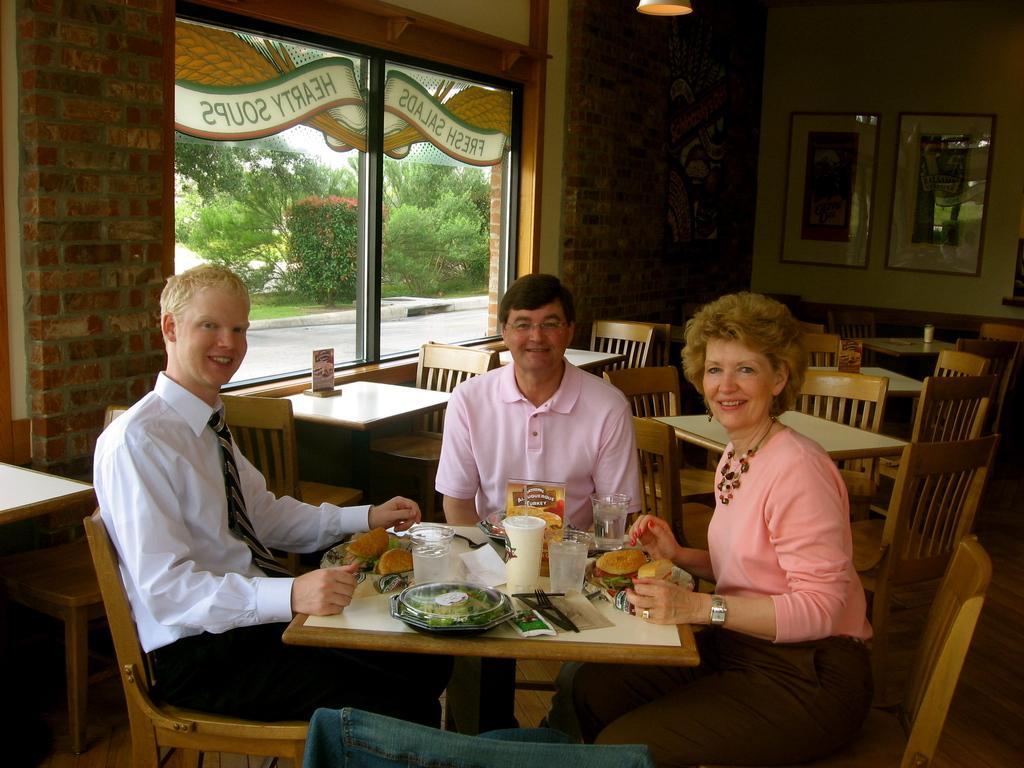In one or two sentences, can you explain what this image depicts? In this picture we can see two men and one woman sitting on chair and smiling and in front of them on table we have glasses, burger, dish, fork, knife, paper, tissue paper and in background we can see tables and chairs, wall with frames, light, window and from window trees. 